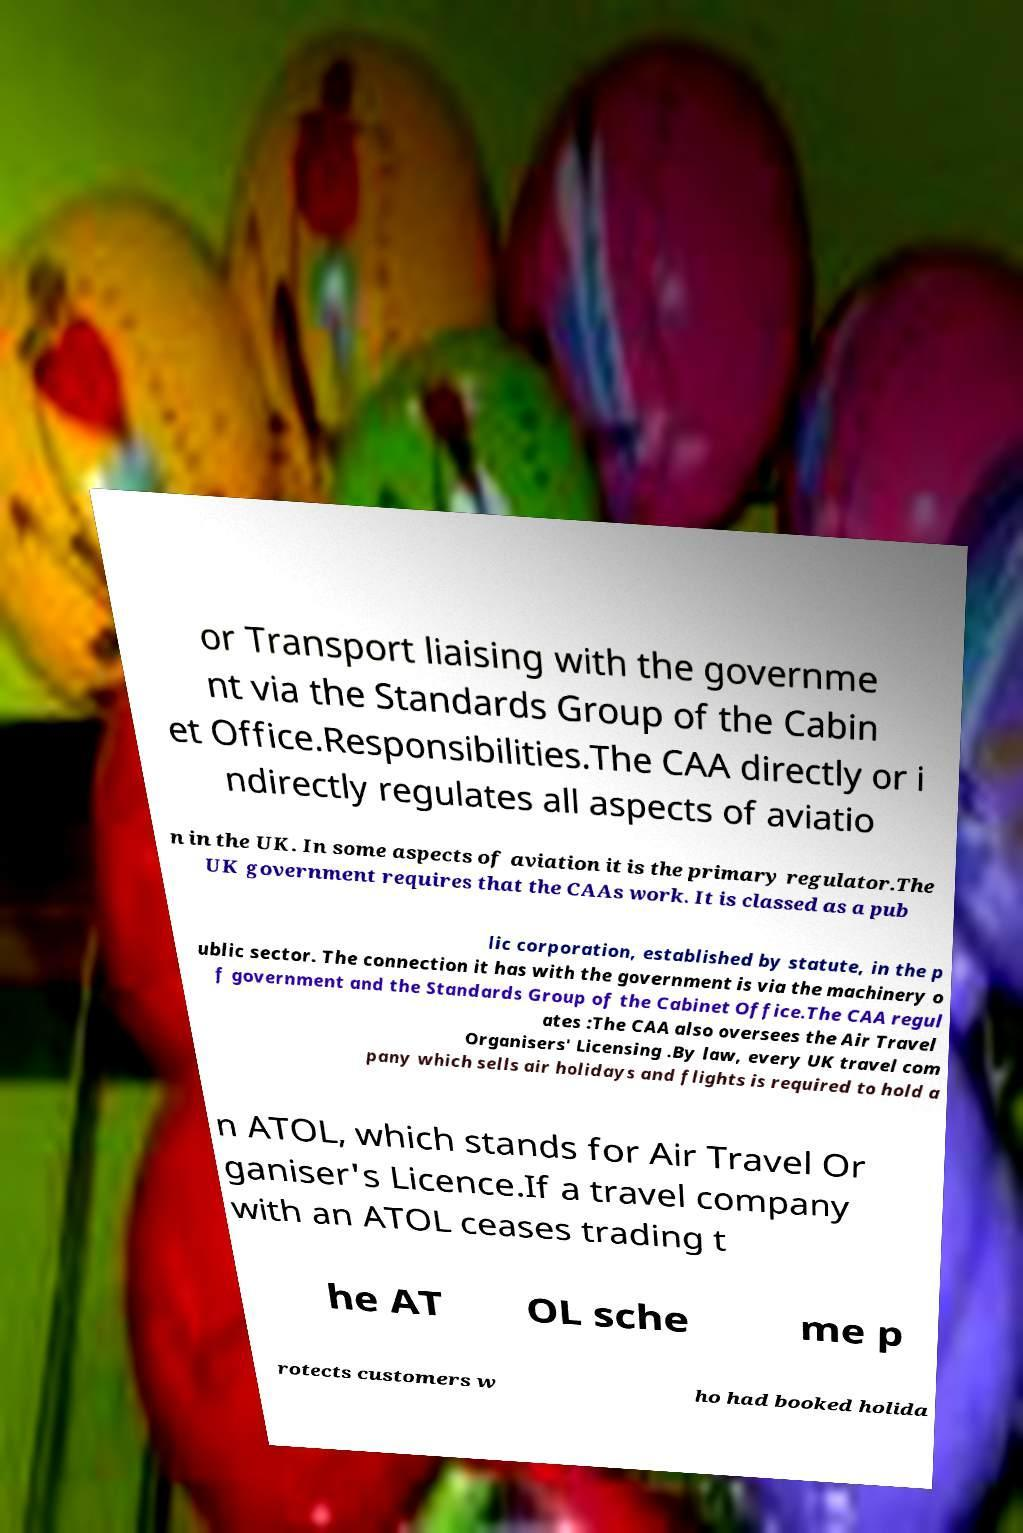Could you assist in decoding the text presented in this image and type it out clearly? or Transport liaising with the governme nt via the Standards Group of the Cabin et Office.Responsibilities.The CAA directly or i ndirectly regulates all aspects of aviatio n in the UK. In some aspects of aviation it is the primary regulator.The UK government requires that the CAAs work. It is classed as a pub lic corporation, established by statute, in the p ublic sector. The connection it has with the government is via the machinery o f government and the Standards Group of the Cabinet Office.The CAA regul ates :The CAA also oversees the Air Travel Organisers' Licensing .By law, every UK travel com pany which sells air holidays and flights is required to hold a n ATOL, which stands for Air Travel Or ganiser's Licence.If a travel company with an ATOL ceases trading t he AT OL sche me p rotects customers w ho had booked holida 